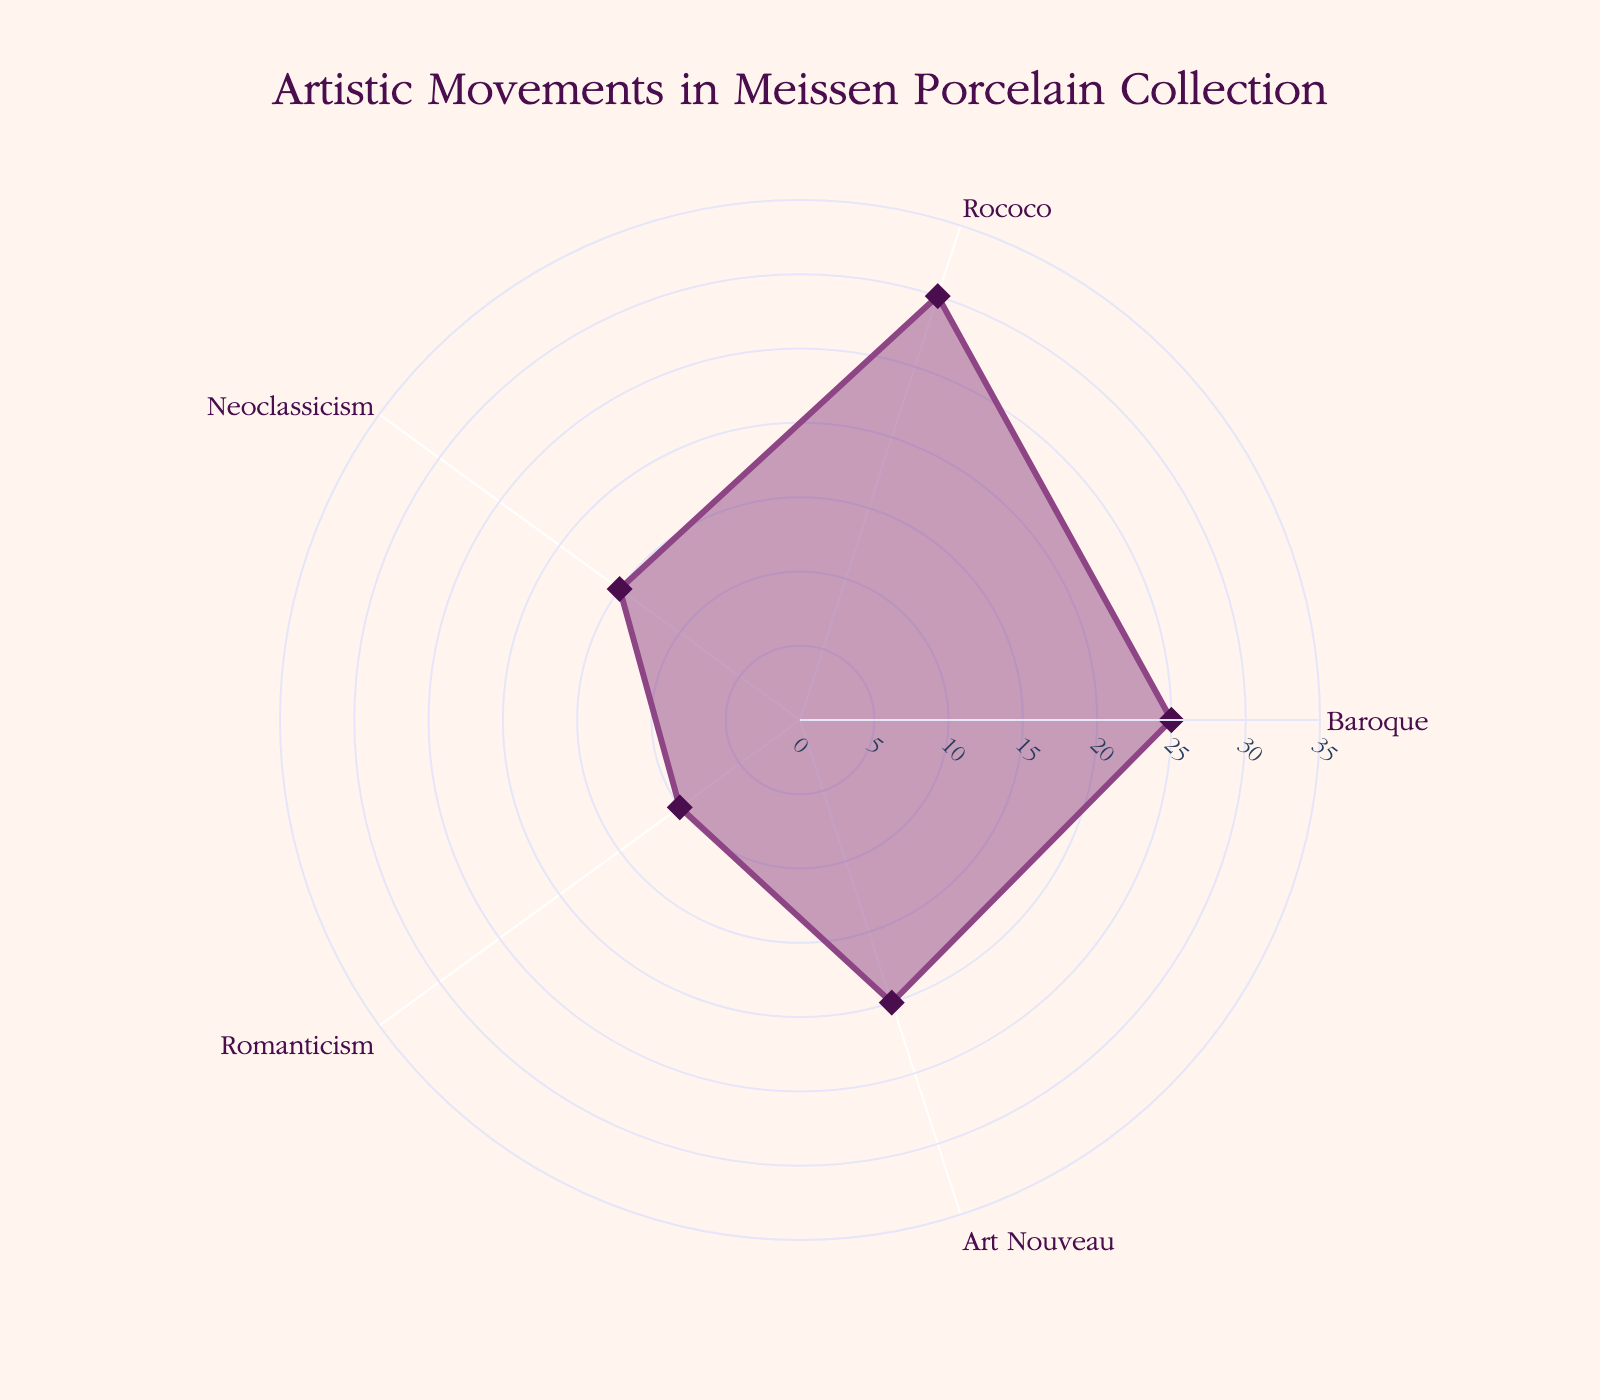What's the title of the figure? The title is usually displayed at the top of the figure. Here it is "Artistic Movements in Meissen Porcelain Collection".
Answer: Artistic Movements in Meissen Porcelain Collection What artistic movements are represented in the figure? The figure labels the different artistic movements around the radar chart. They are Baroque, Rococo, Neoclassicism, Romanticism, and Art Nouveau.
Answer: Baroque, Rococo, Neoclassicism, Romanticism, Art Nouveau Which artistic movement has the highest proportion in the collection? By comparing the proportions on the radar chart, the movement with the highest value is Rococo at 30.
Answer: Rococo What is the combined proportion of Baroque and Art Nouveau influences in the collection? Add the proportions of Baroque and Art Nouveau, which are 25 and 20 respectively: 25 + 20 = 45.
Answer: 45 How much more proportion does Rococo have compared to Neoclassicism? Find the difference between the Rococo proportion (30) and the Neoclassicism proportion (15): 30 - 15 = 15.
Answer: 15 What is the average proportion of all artistic movements in the chart? Sum the proportions (25 + 30 + 15 + 10 + 20 = 100) and divide by the number of proportions (5): 100 / 5 = 20.
Answer: 20 Which two artistic movements have the closest proportions? Compare the proportions to find the closest values: Neoclassicism (15) and Romanticism (10) have the smallest difference of 5.
Answer: Neoclassicism and Romanticism Is the Romanticism movement's influence more or less than half of the Rococo's? Compare half of Rococo's proportion (30/2 = 15) with Romanticism's proportion (10): 10 is less than 15.
Answer: Less Which artistic movement has the smallest proportion? Compare all the proportions to find the smallest value, which is for Romanticism at 10.
Answer: Romanticism Does the figure use a specific color scheme for design elements? The figure uses a purplish color (#8E4585 for lines and markers) and a lighter fill color (rgba(142, 69, 133, 0.5)) with a light background (#FFF5EE).
Answer: Yes 